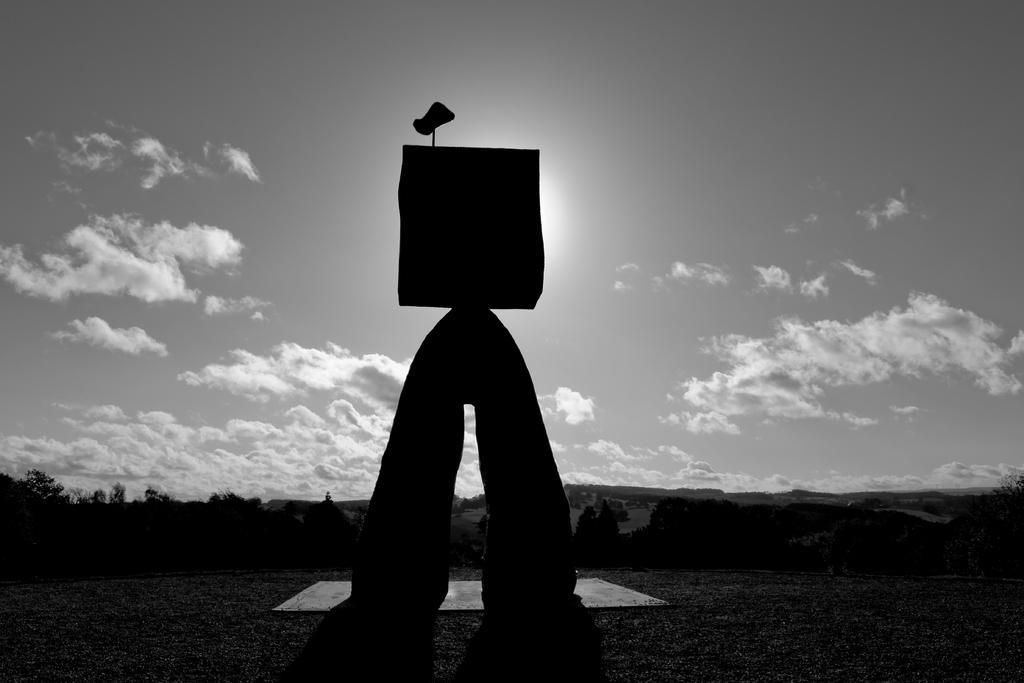How would you summarize this image in a sentence or two? This is a black and white picture. In the middle of the picture, we see something which looks like an arch. There are trees and hills in the background. At the top, we see the sky and the clouds. 